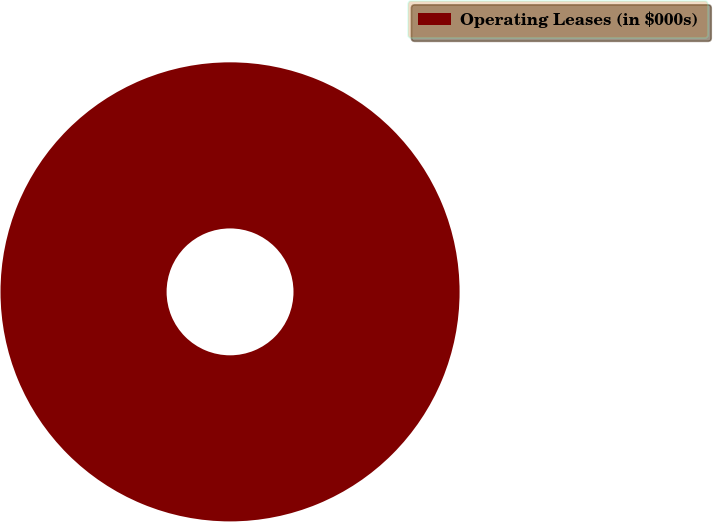<chart> <loc_0><loc_0><loc_500><loc_500><pie_chart><fcel>Operating Leases (in $000s)<nl><fcel>100.0%<nl></chart> 